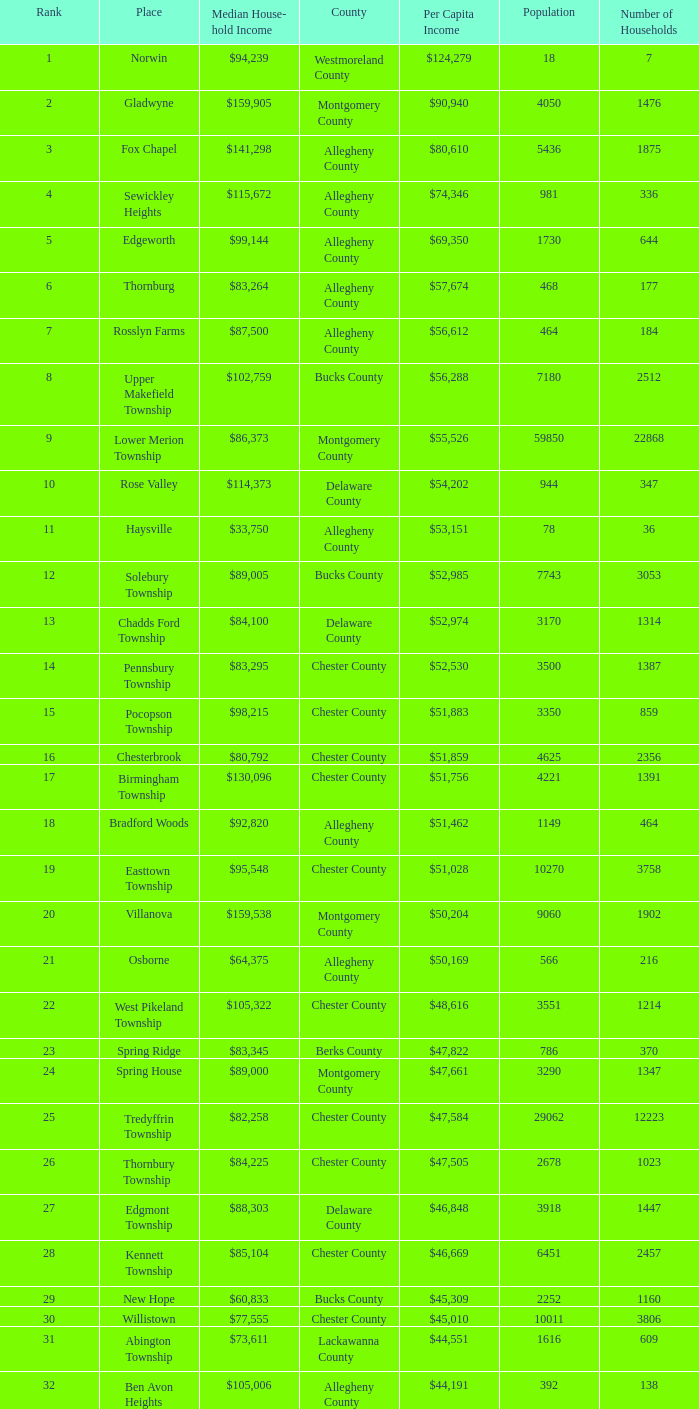What is the per capita income for Fayette County? $42,131. 